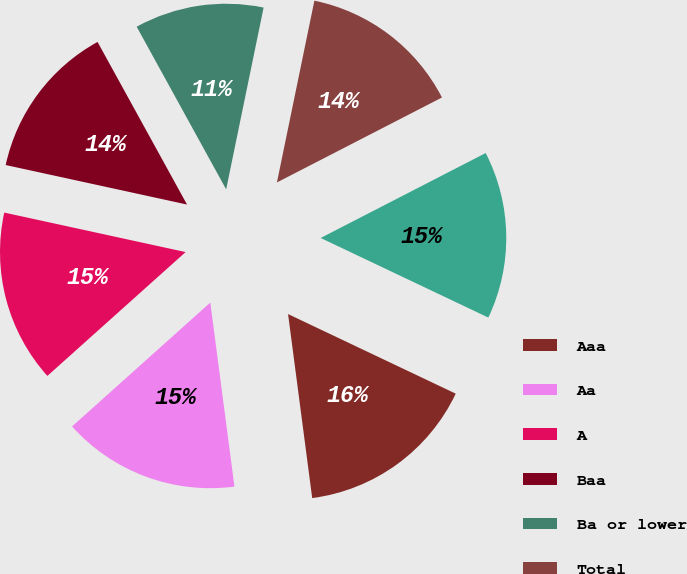Convert chart to OTSL. <chart><loc_0><loc_0><loc_500><loc_500><pie_chart><fcel>Aaa<fcel>Aa<fcel>A<fcel>Baa<fcel>Ba or lower<fcel>Total<fcel>Total tax exempt<nl><fcel>15.87%<fcel>15.45%<fcel>15.04%<fcel>13.58%<fcel>11.24%<fcel>14.2%<fcel>14.62%<nl></chart> 